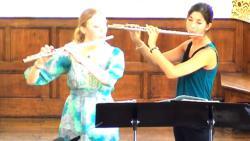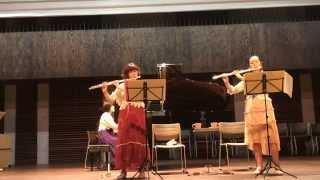The first image is the image on the left, the second image is the image on the right. Considering the images on both sides, is "In the right image, a male is holding two flute-like instruments to his mouth so they form a V-shape." valid? Answer yes or no. No. The first image is the image on the left, the second image is the image on the right. For the images shown, is this caption "Each musician is holding two instruments." true? Answer yes or no. No. 